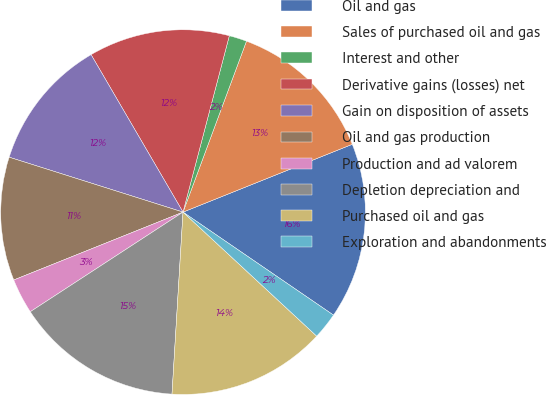<chart> <loc_0><loc_0><loc_500><loc_500><pie_chart><fcel>Oil and gas<fcel>Sales of purchased oil and gas<fcel>Interest and other<fcel>Derivative gains (losses) net<fcel>Gain on disposition of assets<fcel>Oil and gas production<fcel>Production and ad valorem<fcel>Depletion depreciation and<fcel>Purchased oil and gas<fcel>Exploration and abandonments<nl><fcel>15.62%<fcel>13.28%<fcel>1.57%<fcel>12.5%<fcel>11.72%<fcel>10.94%<fcel>3.13%<fcel>14.84%<fcel>14.06%<fcel>2.35%<nl></chart> 